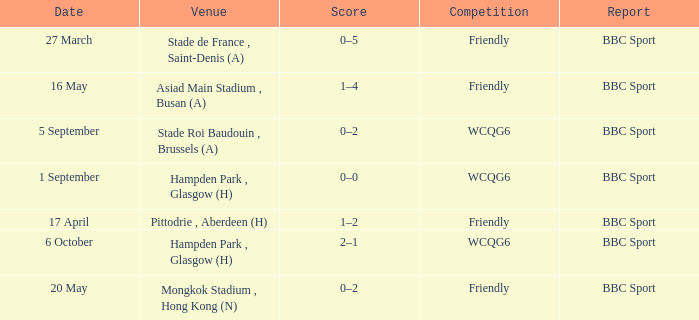What was the score of the game on 1 september? 0–0. 